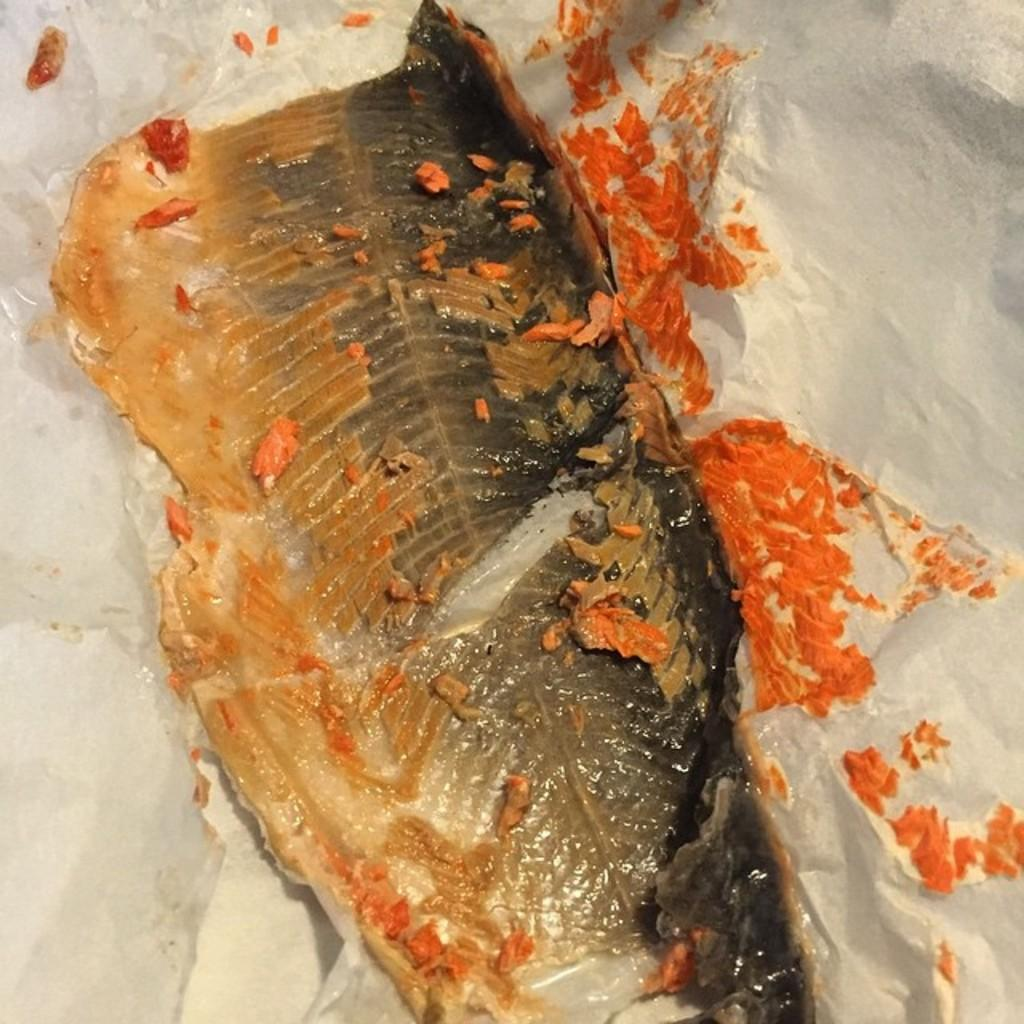What type of animal is in the image? There is a fish in the image. What is located at the bottom of the image? There is a paper at the bottom of the image. What type of apparel is the fish wearing in the image? There is no apparel present on the fish in the image. What type of pickle can be seen in the image? There is no pickle present in the image. 